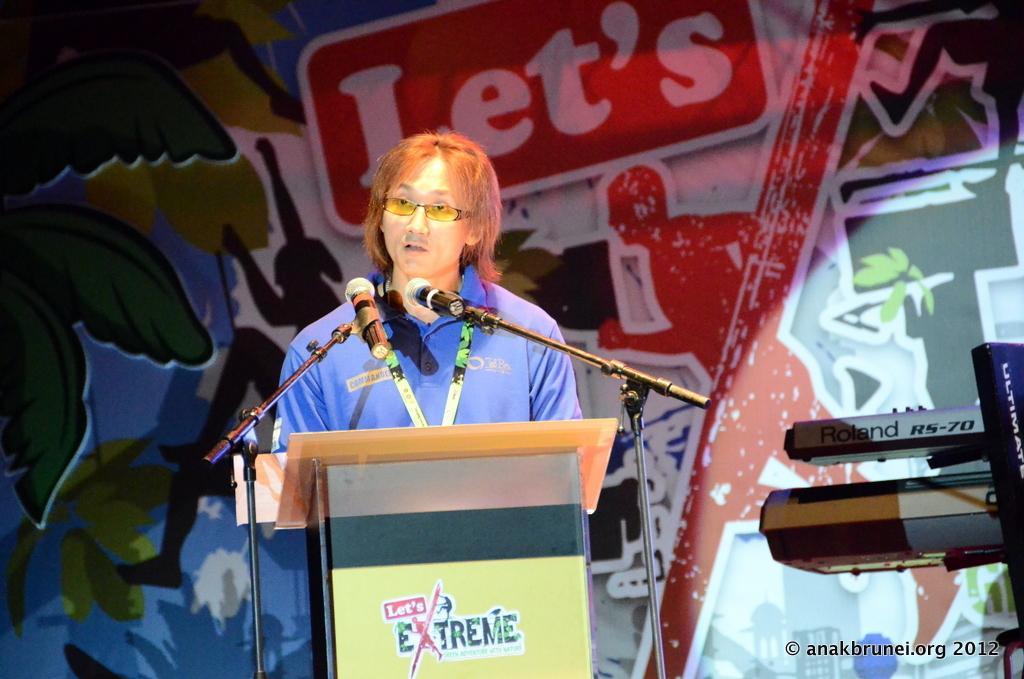Describe this image in one or two sentences. In this picture I can see a podium in front on which there is something written and I can see 2 tripods on which there are mics and in front of the podium I can see a man who is standing. In the background I can see a board on which there is art and something is written. On the right bottom corner of this picture I see the watermark. 